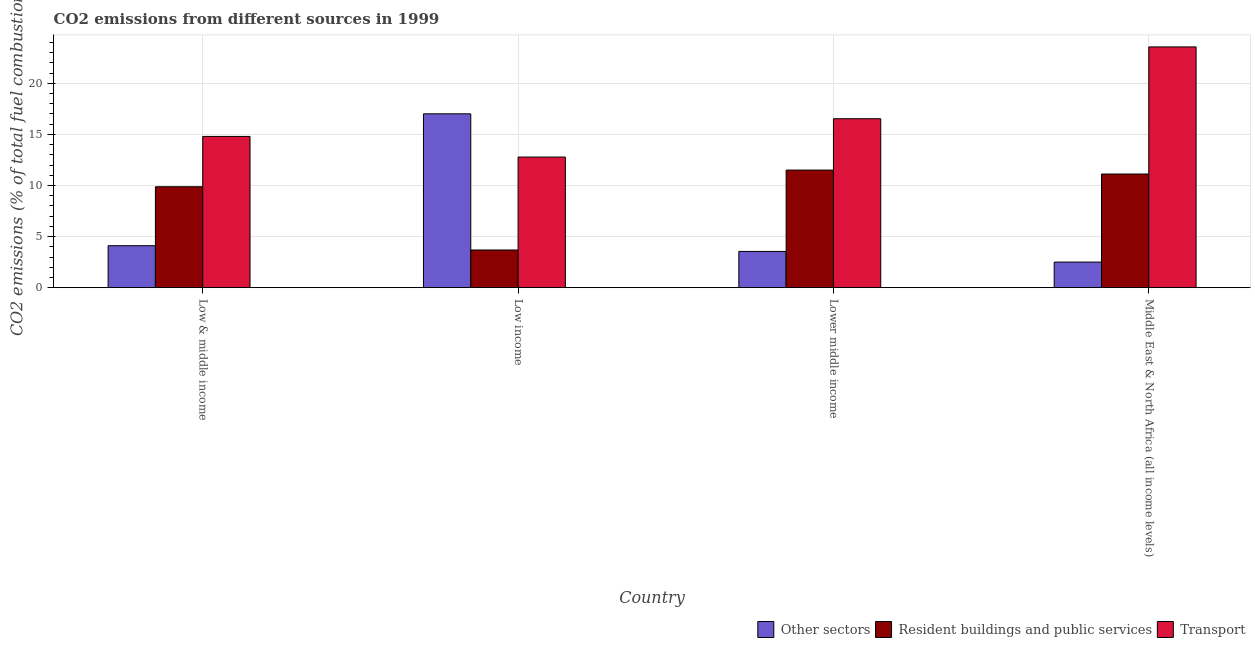How many groups of bars are there?
Provide a short and direct response. 4. Are the number of bars per tick equal to the number of legend labels?
Your answer should be compact. Yes. Are the number of bars on each tick of the X-axis equal?
Your answer should be very brief. Yes. What is the percentage of co2 emissions from transport in Low & middle income?
Your answer should be compact. 14.8. Across all countries, what is the maximum percentage of co2 emissions from other sectors?
Offer a terse response. 17.01. Across all countries, what is the minimum percentage of co2 emissions from resident buildings and public services?
Your answer should be very brief. 3.69. In which country was the percentage of co2 emissions from other sectors maximum?
Make the answer very short. Low income. What is the total percentage of co2 emissions from transport in the graph?
Your answer should be compact. 67.68. What is the difference between the percentage of co2 emissions from other sectors in Low income and that in Middle East & North Africa (all income levels)?
Your response must be concise. 14.51. What is the difference between the percentage of co2 emissions from other sectors in Lower middle income and the percentage of co2 emissions from transport in Low & middle income?
Give a very brief answer. -11.25. What is the average percentage of co2 emissions from other sectors per country?
Your response must be concise. 6.79. What is the difference between the percentage of co2 emissions from resident buildings and public services and percentage of co2 emissions from transport in Middle East & North Africa (all income levels)?
Give a very brief answer. -12.44. What is the ratio of the percentage of co2 emissions from transport in Low income to that in Lower middle income?
Your response must be concise. 0.77. Is the difference between the percentage of co2 emissions from other sectors in Low income and Middle East & North Africa (all income levels) greater than the difference between the percentage of co2 emissions from transport in Low income and Middle East & North Africa (all income levels)?
Your response must be concise. Yes. What is the difference between the highest and the second highest percentage of co2 emissions from other sectors?
Offer a very short reply. 12.91. What is the difference between the highest and the lowest percentage of co2 emissions from transport?
Your answer should be compact. 10.78. In how many countries, is the percentage of co2 emissions from other sectors greater than the average percentage of co2 emissions from other sectors taken over all countries?
Offer a terse response. 1. Is the sum of the percentage of co2 emissions from transport in Low income and Lower middle income greater than the maximum percentage of co2 emissions from other sectors across all countries?
Provide a succinct answer. Yes. What does the 1st bar from the left in Low income represents?
Offer a terse response. Other sectors. What does the 1st bar from the right in Low income represents?
Your answer should be very brief. Transport. Is it the case that in every country, the sum of the percentage of co2 emissions from other sectors and percentage of co2 emissions from resident buildings and public services is greater than the percentage of co2 emissions from transport?
Your answer should be very brief. No. How many countries are there in the graph?
Your response must be concise. 4. What is the difference between two consecutive major ticks on the Y-axis?
Your response must be concise. 5. Are the values on the major ticks of Y-axis written in scientific E-notation?
Offer a very short reply. No. Does the graph contain any zero values?
Give a very brief answer. No. Where does the legend appear in the graph?
Provide a short and direct response. Bottom right. How many legend labels are there?
Provide a short and direct response. 3. How are the legend labels stacked?
Offer a very short reply. Horizontal. What is the title of the graph?
Your answer should be compact. CO2 emissions from different sources in 1999. What is the label or title of the X-axis?
Offer a very short reply. Country. What is the label or title of the Y-axis?
Ensure brevity in your answer.  CO2 emissions (% of total fuel combustion). What is the CO2 emissions (% of total fuel combustion) of Other sectors in Low & middle income?
Offer a very short reply. 4.11. What is the CO2 emissions (% of total fuel combustion) in Resident buildings and public services in Low & middle income?
Offer a very short reply. 9.88. What is the CO2 emissions (% of total fuel combustion) of Transport in Low & middle income?
Your response must be concise. 14.8. What is the CO2 emissions (% of total fuel combustion) in Other sectors in Low income?
Your response must be concise. 17.01. What is the CO2 emissions (% of total fuel combustion) in Resident buildings and public services in Low income?
Make the answer very short. 3.69. What is the CO2 emissions (% of total fuel combustion) of Transport in Low income?
Ensure brevity in your answer.  12.78. What is the CO2 emissions (% of total fuel combustion) in Other sectors in Lower middle income?
Your response must be concise. 3.55. What is the CO2 emissions (% of total fuel combustion) in Resident buildings and public services in Lower middle income?
Ensure brevity in your answer.  11.51. What is the CO2 emissions (% of total fuel combustion) of Transport in Lower middle income?
Provide a short and direct response. 16.53. What is the CO2 emissions (% of total fuel combustion) of Other sectors in Middle East & North Africa (all income levels)?
Your answer should be very brief. 2.5. What is the CO2 emissions (% of total fuel combustion) in Resident buildings and public services in Middle East & North Africa (all income levels)?
Make the answer very short. 11.12. What is the CO2 emissions (% of total fuel combustion) of Transport in Middle East & North Africa (all income levels)?
Make the answer very short. 23.56. Across all countries, what is the maximum CO2 emissions (% of total fuel combustion) of Other sectors?
Make the answer very short. 17.01. Across all countries, what is the maximum CO2 emissions (% of total fuel combustion) in Resident buildings and public services?
Provide a short and direct response. 11.51. Across all countries, what is the maximum CO2 emissions (% of total fuel combustion) of Transport?
Provide a short and direct response. 23.56. Across all countries, what is the minimum CO2 emissions (% of total fuel combustion) in Other sectors?
Offer a terse response. 2.5. Across all countries, what is the minimum CO2 emissions (% of total fuel combustion) in Resident buildings and public services?
Ensure brevity in your answer.  3.69. Across all countries, what is the minimum CO2 emissions (% of total fuel combustion) in Transport?
Give a very brief answer. 12.78. What is the total CO2 emissions (% of total fuel combustion) in Other sectors in the graph?
Ensure brevity in your answer.  27.17. What is the total CO2 emissions (% of total fuel combustion) of Resident buildings and public services in the graph?
Your answer should be very brief. 36.2. What is the total CO2 emissions (% of total fuel combustion) of Transport in the graph?
Provide a short and direct response. 67.68. What is the difference between the CO2 emissions (% of total fuel combustion) in Other sectors in Low & middle income and that in Low income?
Offer a very short reply. -12.91. What is the difference between the CO2 emissions (% of total fuel combustion) in Resident buildings and public services in Low & middle income and that in Low income?
Make the answer very short. 6.19. What is the difference between the CO2 emissions (% of total fuel combustion) of Transport in Low & middle income and that in Low income?
Provide a succinct answer. 2.02. What is the difference between the CO2 emissions (% of total fuel combustion) in Other sectors in Low & middle income and that in Lower middle income?
Keep it short and to the point. 0.56. What is the difference between the CO2 emissions (% of total fuel combustion) of Resident buildings and public services in Low & middle income and that in Lower middle income?
Make the answer very short. -1.63. What is the difference between the CO2 emissions (% of total fuel combustion) of Transport in Low & middle income and that in Lower middle income?
Your answer should be very brief. -1.73. What is the difference between the CO2 emissions (% of total fuel combustion) of Other sectors in Low & middle income and that in Middle East & North Africa (all income levels)?
Give a very brief answer. 1.6. What is the difference between the CO2 emissions (% of total fuel combustion) of Resident buildings and public services in Low & middle income and that in Middle East & North Africa (all income levels)?
Keep it short and to the point. -1.25. What is the difference between the CO2 emissions (% of total fuel combustion) in Transport in Low & middle income and that in Middle East & North Africa (all income levels)?
Keep it short and to the point. -8.76. What is the difference between the CO2 emissions (% of total fuel combustion) in Other sectors in Low income and that in Lower middle income?
Your answer should be compact. 13.47. What is the difference between the CO2 emissions (% of total fuel combustion) in Resident buildings and public services in Low income and that in Lower middle income?
Make the answer very short. -7.82. What is the difference between the CO2 emissions (% of total fuel combustion) of Transport in Low income and that in Lower middle income?
Ensure brevity in your answer.  -3.75. What is the difference between the CO2 emissions (% of total fuel combustion) of Other sectors in Low income and that in Middle East & North Africa (all income levels)?
Provide a short and direct response. 14.51. What is the difference between the CO2 emissions (% of total fuel combustion) of Resident buildings and public services in Low income and that in Middle East & North Africa (all income levels)?
Your response must be concise. -7.44. What is the difference between the CO2 emissions (% of total fuel combustion) in Transport in Low income and that in Middle East & North Africa (all income levels)?
Ensure brevity in your answer.  -10.78. What is the difference between the CO2 emissions (% of total fuel combustion) in Other sectors in Lower middle income and that in Middle East & North Africa (all income levels)?
Your answer should be compact. 1.04. What is the difference between the CO2 emissions (% of total fuel combustion) of Resident buildings and public services in Lower middle income and that in Middle East & North Africa (all income levels)?
Provide a short and direct response. 0.38. What is the difference between the CO2 emissions (% of total fuel combustion) in Transport in Lower middle income and that in Middle East & North Africa (all income levels)?
Make the answer very short. -7.03. What is the difference between the CO2 emissions (% of total fuel combustion) of Other sectors in Low & middle income and the CO2 emissions (% of total fuel combustion) of Resident buildings and public services in Low income?
Ensure brevity in your answer.  0.42. What is the difference between the CO2 emissions (% of total fuel combustion) in Other sectors in Low & middle income and the CO2 emissions (% of total fuel combustion) in Transport in Low income?
Provide a succinct answer. -8.68. What is the difference between the CO2 emissions (% of total fuel combustion) of Resident buildings and public services in Low & middle income and the CO2 emissions (% of total fuel combustion) of Transport in Low income?
Provide a succinct answer. -2.91. What is the difference between the CO2 emissions (% of total fuel combustion) of Other sectors in Low & middle income and the CO2 emissions (% of total fuel combustion) of Resident buildings and public services in Lower middle income?
Provide a succinct answer. -7.4. What is the difference between the CO2 emissions (% of total fuel combustion) in Other sectors in Low & middle income and the CO2 emissions (% of total fuel combustion) in Transport in Lower middle income?
Provide a short and direct response. -12.43. What is the difference between the CO2 emissions (% of total fuel combustion) in Resident buildings and public services in Low & middle income and the CO2 emissions (% of total fuel combustion) in Transport in Lower middle income?
Offer a terse response. -6.66. What is the difference between the CO2 emissions (% of total fuel combustion) of Other sectors in Low & middle income and the CO2 emissions (% of total fuel combustion) of Resident buildings and public services in Middle East & North Africa (all income levels)?
Your answer should be very brief. -7.02. What is the difference between the CO2 emissions (% of total fuel combustion) of Other sectors in Low & middle income and the CO2 emissions (% of total fuel combustion) of Transport in Middle East & North Africa (all income levels)?
Keep it short and to the point. -19.46. What is the difference between the CO2 emissions (% of total fuel combustion) in Resident buildings and public services in Low & middle income and the CO2 emissions (% of total fuel combustion) in Transport in Middle East & North Africa (all income levels)?
Provide a short and direct response. -13.69. What is the difference between the CO2 emissions (% of total fuel combustion) in Other sectors in Low income and the CO2 emissions (% of total fuel combustion) in Resident buildings and public services in Lower middle income?
Give a very brief answer. 5.51. What is the difference between the CO2 emissions (% of total fuel combustion) in Other sectors in Low income and the CO2 emissions (% of total fuel combustion) in Transport in Lower middle income?
Offer a very short reply. 0.48. What is the difference between the CO2 emissions (% of total fuel combustion) in Resident buildings and public services in Low income and the CO2 emissions (% of total fuel combustion) in Transport in Lower middle income?
Offer a terse response. -12.85. What is the difference between the CO2 emissions (% of total fuel combustion) in Other sectors in Low income and the CO2 emissions (% of total fuel combustion) in Resident buildings and public services in Middle East & North Africa (all income levels)?
Give a very brief answer. 5.89. What is the difference between the CO2 emissions (% of total fuel combustion) in Other sectors in Low income and the CO2 emissions (% of total fuel combustion) in Transport in Middle East & North Africa (all income levels)?
Give a very brief answer. -6.55. What is the difference between the CO2 emissions (% of total fuel combustion) in Resident buildings and public services in Low income and the CO2 emissions (% of total fuel combustion) in Transport in Middle East & North Africa (all income levels)?
Your answer should be very brief. -19.88. What is the difference between the CO2 emissions (% of total fuel combustion) of Other sectors in Lower middle income and the CO2 emissions (% of total fuel combustion) of Resident buildings and public services in Middle East & North Africa (all income levels)?
Ensure brevity in your answer.  -7.58. What is the difference between the CO2 emissions (% of total fuel combustion) of Other sectors in Lower middle income and the CO2 emissions (% of total fuel combustion) of Transport in Middle East & North Africa (all income levels)?
Ensure brevity in your answer.  -20.01. What is the difference between the CO2 emissions (% of total fuel combustion) of Resident buildings and public services in Lower middle income and the CO2 emissions (% of total fuel combustion) of Transport in Middle East & North Africa (all income levels)?
Your answer should be very brief. -12.05. What is the average CO2 emissions (% of total fuel combustion) in Other sectors per country?
Ensure brevity in your answer.  6.79. What is the average CO2 emissions (% of total fuel combustion) of Resident buildings and public services per country?
Your answer should be very brief. 9.05. What is the average CO2 emissions (% of total fuel combustion) in Transport per country?
Your answer should be very brief. 16.92. What is the difference between the CO2 emissions (% of total fuel combustion) in Other sectors and CO2 emissions (% of total fuel combustion) in Resident buildings and public services in Low & middle income?
Give a very brief answer. -5.77. What is the difference between the CO2 emissions (% of total fuel combustion) in Other sectors and CO2 emissions (% of total fuel combustion) in Transport in Low & middle income?
Make the answer very short. -10.69. What is the difference between the CO2 emissions (% of total fuel combustion) of Resident buildings and public services and CO2 emissions (% of total fuel combustion) of Transport in Low & middle income?
Keep it short and to the point. -4.92. What is the difference between the CO2 emissions (% of total fuel combustion) in Other sectors and CO2 emissions (% of total fuel combustion) in Resident buildings and public services in Low income?
Your answer should be very brief. 13.33. What is the difference between the CO2 emissions (% of total fuel combustion) of Other sectors and CO2 emissions (% of total fuel combustion) of Transport in Low income?
Provide a short and direct response. 4.23. What is the difference between the CO2 emissions (% of total fuel combustion) in Resident buildings and public services and CO2 emissions (% of total fuel combustion) in Transport in Low income?
Keep it short and to the point. -9.1. What is the difference between the CO2 emissions (% of total fuel combustion) in Other sectors and CO2 emissions (% of total fuel combustion) in Resident buildings and public services in Lower middle income?
Provide a succinct answer. -7.96. What is the difference between the CO2 emissions (% of total fuel combustion) of Other sectors and CO2 emissions (% of total fuel combustion) of Transport in Lower middle income?
Give a very brief answer. -12.99. What is the difference between the CO2 emissions (% of total fuel combustion) of Resident buildings and public services and CO2 emissions (% of total fuel combustion) of Transport in Lower middle income?
Your answer should be compact. -5.03. What is the difference between the CO2 emissions (% of total fuel combustion) of Other sectors and CO2 emissions (% of total fuel combustion) of Resident buildings and public services in Middle East & North Africa (all income levels)?
Your answer should be very brief. -8.62. What is the difference between the CO2 emissions (% of total fuel combustion) in Other sectors and CO2 emissions (% of total fuel combustion) in Transport in Middle East & North Africa (all income levels)?
Offer a terse response. -21.06. What is the difference between the CO2 emissions (% of total fuel combustion) in Resident buildings and public services and CO2 emissions (% of total fuel combustion) in Transport in Middle East & North Africa (all income levels)?
Your response must be concise. -12.44. What is the ratio of the CO2 emissions (% of total fuel combustion) in Other sectors in Low & middle income to that in Low income?
Your response must be concise. 0.24. What is the ratio of the CO2 emissions (% of total fuel combustion) of Resident buildings and public services in Low & middle income to that in Low income?
Provide a succinct answer. 2.68. What is the ratio of the CO2 emissions (% of total fuel combustion) of Transport in Low & middle income to that in Low income?
Make the answer very short. 1.16. What is the ratio of the CO2 emissions (% of total fuel combustion) in Other sectors in Low & middle income to that in Lower middle income?
Make the answer very short. 1.16. What is the ratio of the CO2 emissions (% of total fuel combustion) in Resident buildings and public services in Low & middle income to that in Lower middle income?
Keep it short and to the point. 0.86. What is the ratio of the CO2 emissions (% of total fuel combustion) of Transport in Low & middle income to that in Lower middle income?
Provide a short and direct response. 0.9. What is the ratio of the CO2 emissions (% of total fuel combustion) in Other sectors in Low & middle income to that in Middle East & North Africa (all income levels)?
Provide a succinct answer. 1.64. What is the ratio of the CO2 emissions (% of total fuel combustion) in Resident buildings and public services in Low & middle income to that in Middle East & North Africa (all income levels)?
Your answer should be compact. 0.89. What is the ratio of the CO2 emissions (% of total fuel combustion) of Transport in Low & middle income to that in Middle East & North Africa (all income levels)?
Ensure brevity in your answer.  0.63. What is the ratio of the CO2 emissions (% of total fuel combustion) in Other sectors in Low income to that in Lower middle income?
Ensure brevity in your answer.  4.79. What is the ratio of the CO2 emissions (% of total fuel combustion) of Resident buildings and public services in Low income to that in Lower middle income?
Provide a short and direct response. 0.32. What is the ratio of the CO2 emissions (% of total fuel combustion) in Transport in Low income to that in Lower middle income?
Give a very brief answer. 0.77. What is the ratio of the CO2 emissions (% of total fuel combustion) of Other sectors in Low income to that in Middle East & North Africa (all income levels)?
Ensure brevity in your answer.  6.8. What is the ratio of the CO2 emissions (% of total fuel combustion) in Resident buildings and public services in Low income to that in Middle East & North Africa (all income levels)?
Your answer should be compact. 0.33. What is the ratio of the CO2 emissions (% of total fuel combustion) in Transport in Low income to that in Middle East & North Africa (all income levels)?
Your response must be concise. 0.54. What is the ratio of the CO2 emissions (% of total fuel combustion) of Other sectors in Lower middle income to that in Middle East & North Africa (all income levels)?
Provide a succinct answer. 1.42. What is the ratio of the CO2 emissions (% of total fuel combustion) of Resident buildings and public services in Lower middle income to that in Middle East & North Africa (all income levels)?
Your answer should be compact. 1.03. What is the ratio of the CO2 emissions (% of total fuel combustion) in Transport in Lower middle income to that in Middle East & North Africa (all income levels)?
Provide a succinct answer. 0.7. What is the difference between the highest and the second highest CO2 emissions (% of total fuel combustion) of Other sectors?
Give a very brief answer. 12.91. What is the difference between the highest and the second highest CO2 emissions (% of total fuel combustion) in Resident buildings and public services?
Keep it short and to the point. 0.38. What is the difference between the highest and the second highest CO2 emissions (% of total fuel combustion) of Transport?
Make the answer very short. 7.03. What is the difference between the highest and the lowest CO2 emissions (% of total fuel combustion) in Other sectors?
Offer a terse response. 14.51. What is the difference between the highest and the lowest CO2 emissions (% of total fuel combustion) of Resident buildings and public services?
Your answer should be very brief. 7.82. What is the difference between the highest and the lowest CO2 emissions (% of total fuel combustion) of Transport?
Offer a terse response. 10.78. 